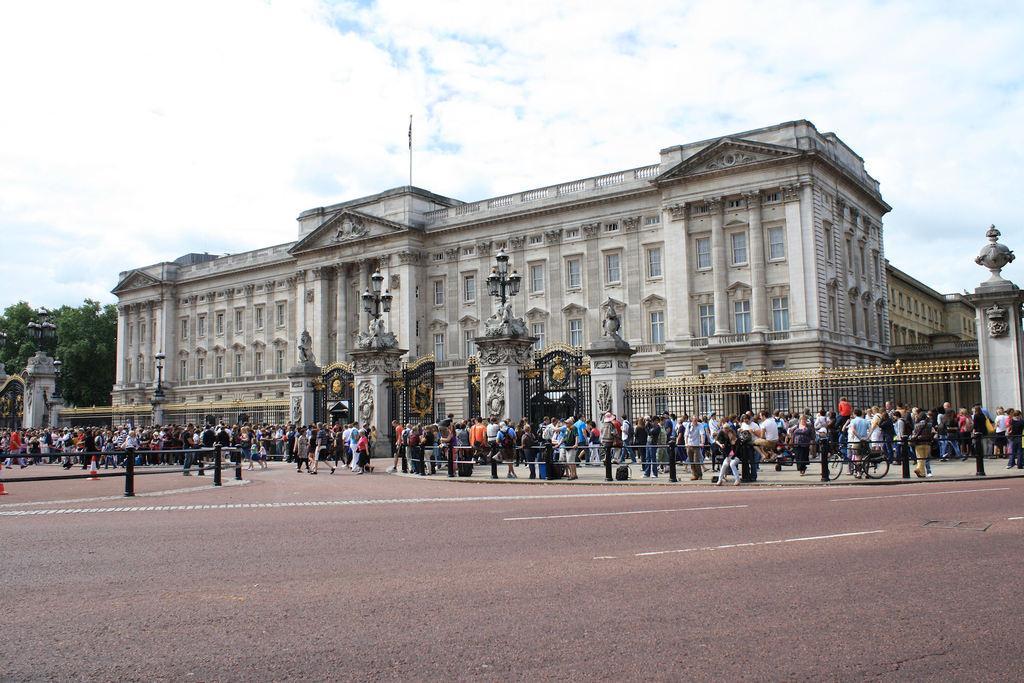Describe this image in one or two sentences. In this image we can see buildings, glass windows, beside that we can see metal fencing and gates and we can see lamps. And we can see trees on the left side. And we can see people walking, we can see a bicycle, beside that we can see the fence and the road, at the top we can see the sky with clouds. 